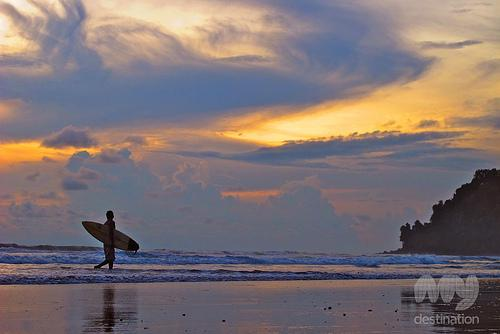What is the core subject in the image and their action? The main subject is a man carrying a surfboard while walking on a sandy beach near the water. Mention the primary scene in the image and the activity taking place. A beach scene with wet sand, seashells, and crashing waves, featuring a man carrying a surfboard along the shore. What is the most prominent element in the picture and what are they doing? The main element is a man walking on the beach, clutching a surfboard, with a wave approaching in the background. Concisely narrate the essential part of the image and what's occurring. The image captures a man strolling on the beach, holding a surfboard with an approaching ocean wave. Briefly explain the image's main focus and what is happening. The image shows a man walking on a beach, holding a surfboard as a small ocean wave approaches the shore. Highlight the central focus of the image and describe the ongoing event. A man carrying a surfboard is walking on the beach, with a beautiful ocean wave coming towards the shore. Give a brief account of the main subject in the image and their action. The image features a man holding a surfboard as he walks on the sandy beach with an incoming wave. Provide a succinct description of the main subject and the situation. A man is walking along a beach with a surfboard in hand, while an ocean wave crashes nearby. In one sentence, describe the central object and its context. A man is walking on the beach with a surfboard, facing an incoming ocean wave on a cloudy day. Identify the primary figure in the photo and describe their activity. The central figure is a man walking on the beach, carrying a surfboard as a wave rolls in. 